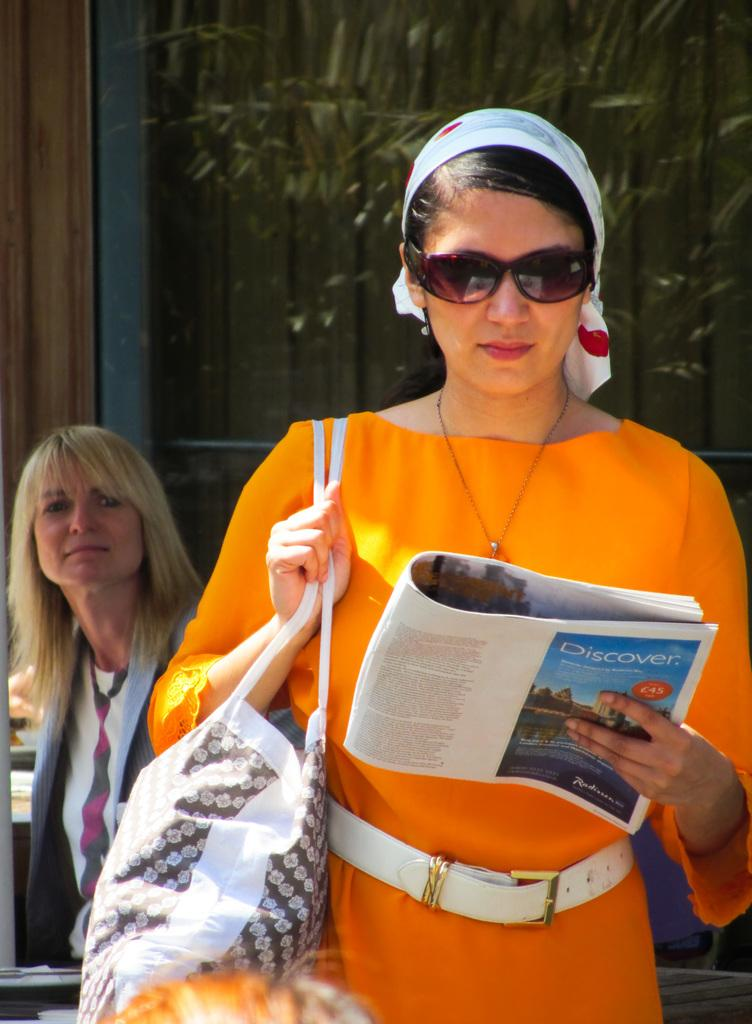What is the woman in the image holding in one hand? The woman is holding a bag in one hand. What is the woman in the image holding in the other hand? The woman is holding a book in the other hand. What can be seen in the background of the image? There is a plant and a wall in the background of the image. Are there any other people visible in the image? Yes, there is another woman in the background of the image. What type of cheese is the jellyfish eating in the image? There is no jellyfish or cheese present in the image. 